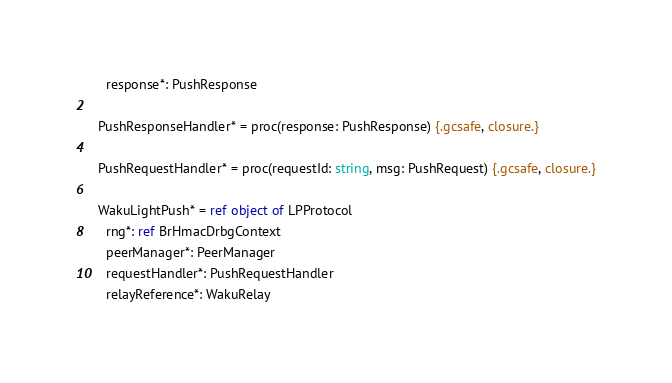<code> <loc_0><loc_0><loc_500><loc_500><_Nim_>    response*: PushResponse

  PushResponseHandler* = proc(response: PushResponse) {.gcsafe, closure.}

  PushRequestHandler* = proc(requestId: string, msg: PushRequest) {.gcsafe, closure.}

  WakuLightPush* = ref object of LPProtocol
    rng*: ref BrHmacDrbgContext
    peerManager*: PeerManager
    requestHandler*: PushRequestHandler
    relayReference*: WakuRelay
</code> 